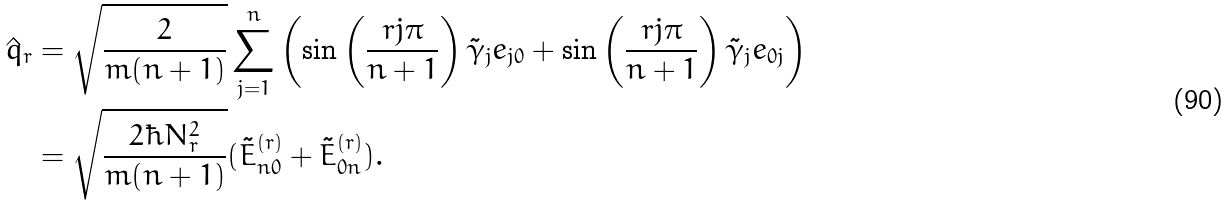Convert formula to latex. <formula><loc_0><loc_0><loc_500><loc_500>\hat { q } _ { r } & = \sqrt { \frac { 2 } { m ( n + 1 ) } } \sum _ { j = 1 } ^ { n } \left ( \sin \left ( \frac { r j \pi } { n + 1 } \right ) \tilde { \gamma } _ { j } e _ { j 0 } + \sin \left ( \frac { r j \pi } { n + 1 } \right ) \tilde { \gamma } _ { j } e _ { 0 j } \right ) \\ & = \sqrt { \frac { 2 \hbar { N } _ { r } ^ { 2 } } { m ( n + 1 ) } } ( \tilde { E } _ { n 0 } ^ { ( r ) } + \tilde { E } _ { 0 n } ^ { ( r ) } ) .</formula> 